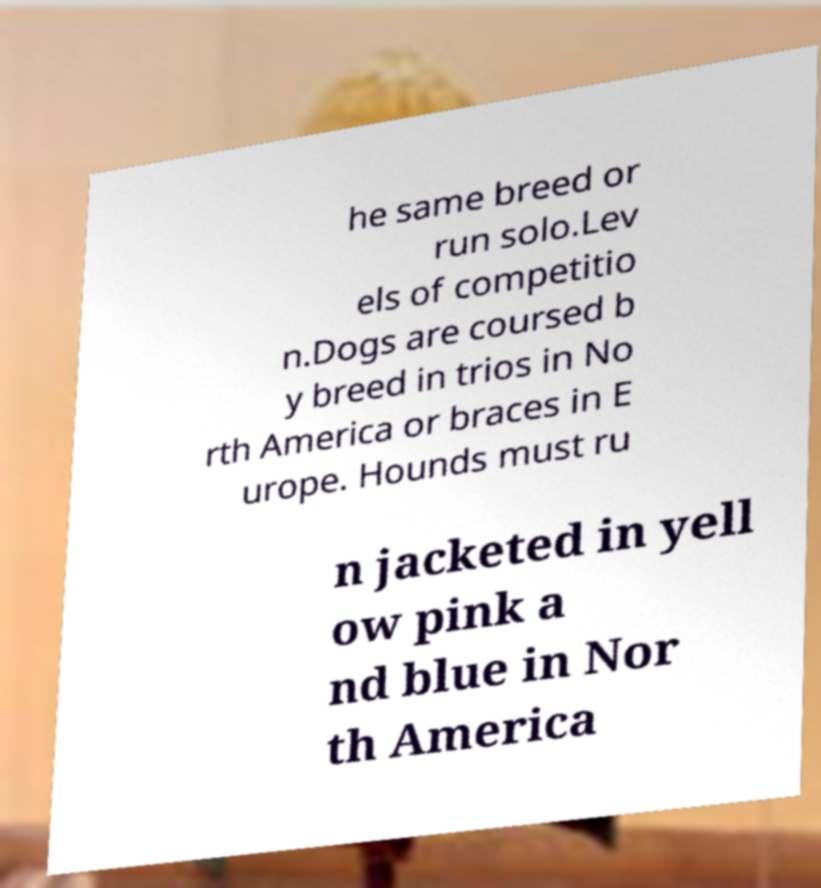Could you extract and type out the text from this image? he same breed or run solo.Lev els of competitio n.Dogs are coursed b y breed in trios in No rth America or braces in E urope. Hounds must ru n jacketed in yell ow pink a nd blue in Nor th America 